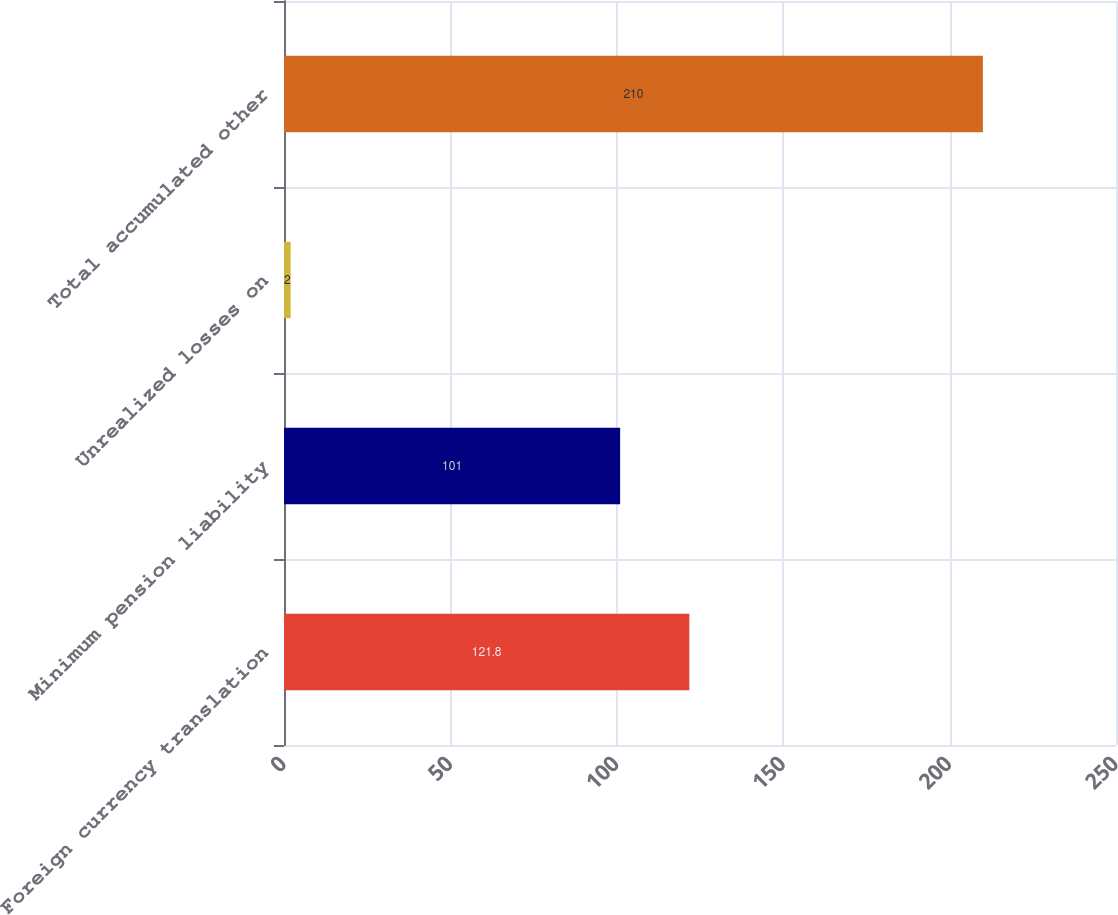Convert chart. <chart><loc_0><loc_0><loc_500><loc_500><bar_chart><fcel>Foreign currency translation<fcel>Minimum pension liability<fcel>Unrealized losses on<fcel>Total accumulated other<nl><fcel>121.8<fcel>101<fcel>2<fcel>210<nl></chart> 